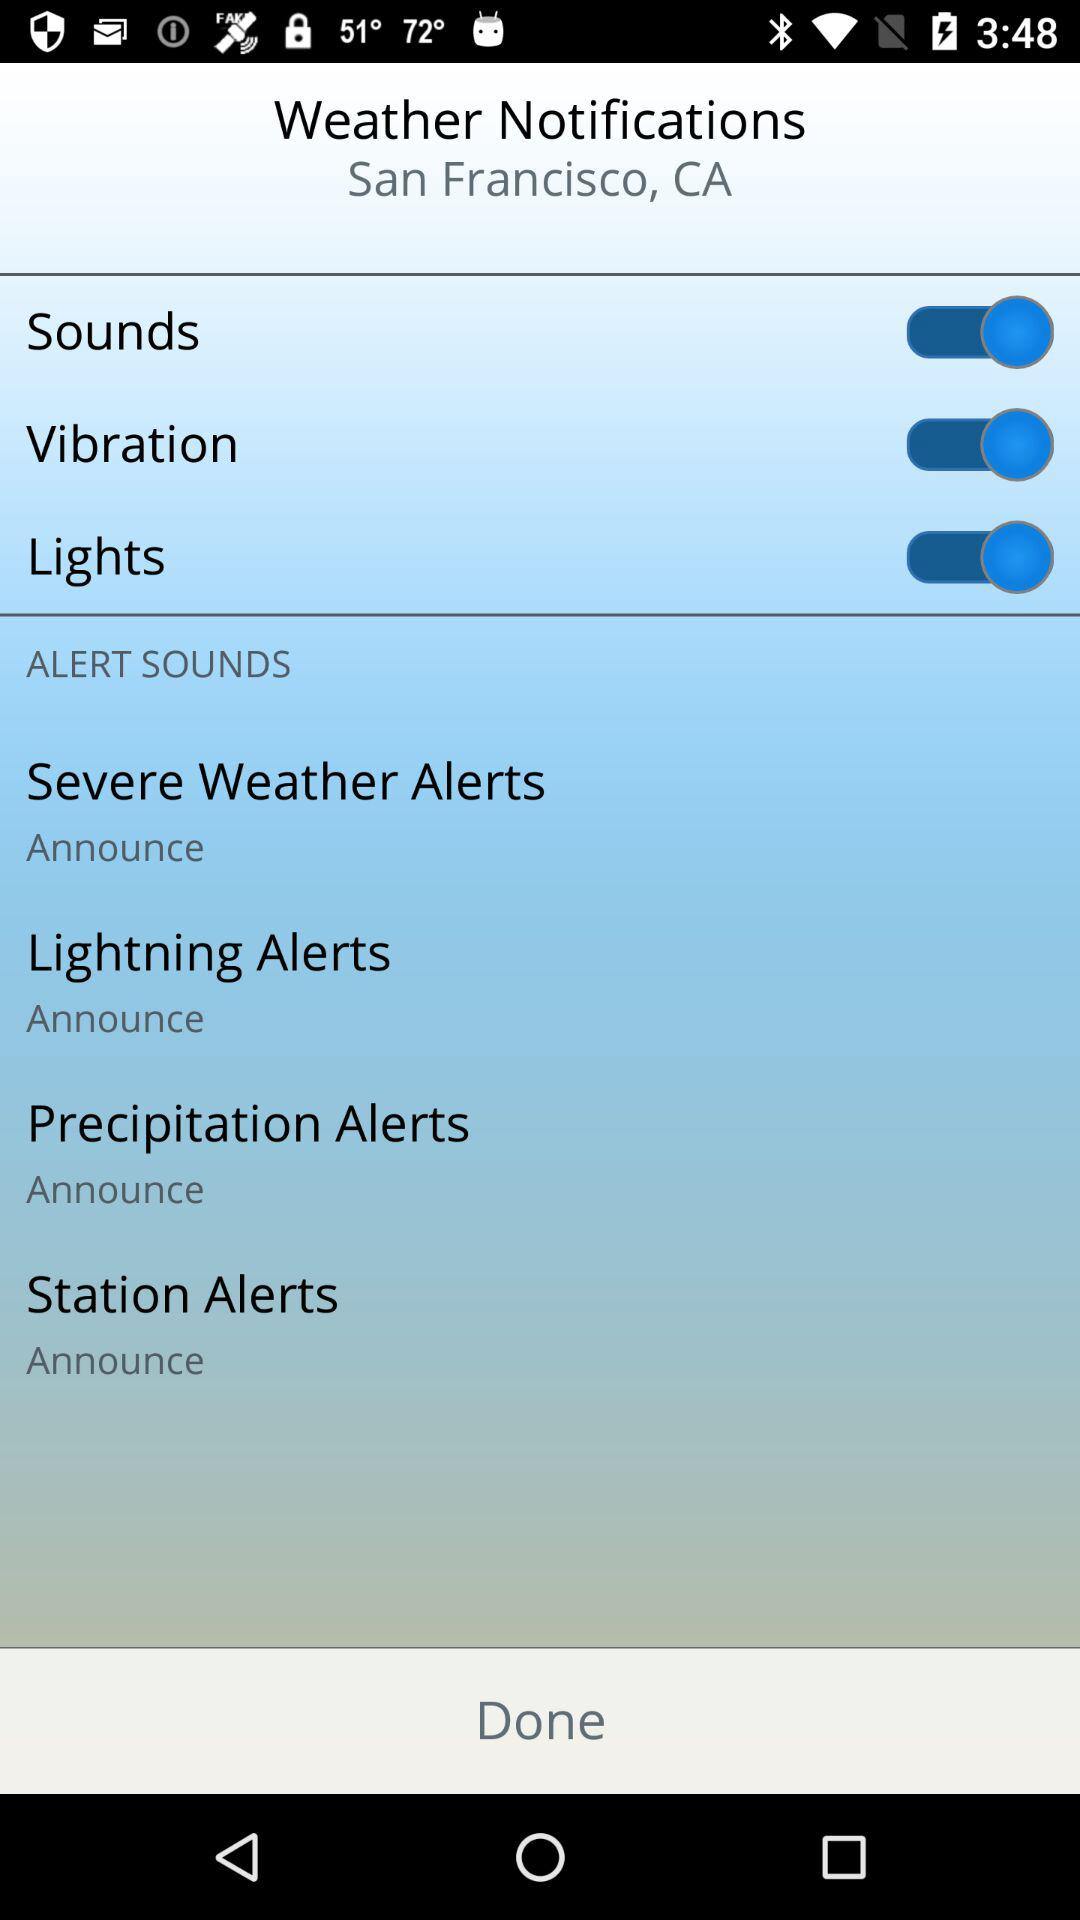What is the location? The location is San Francisco, CA. 